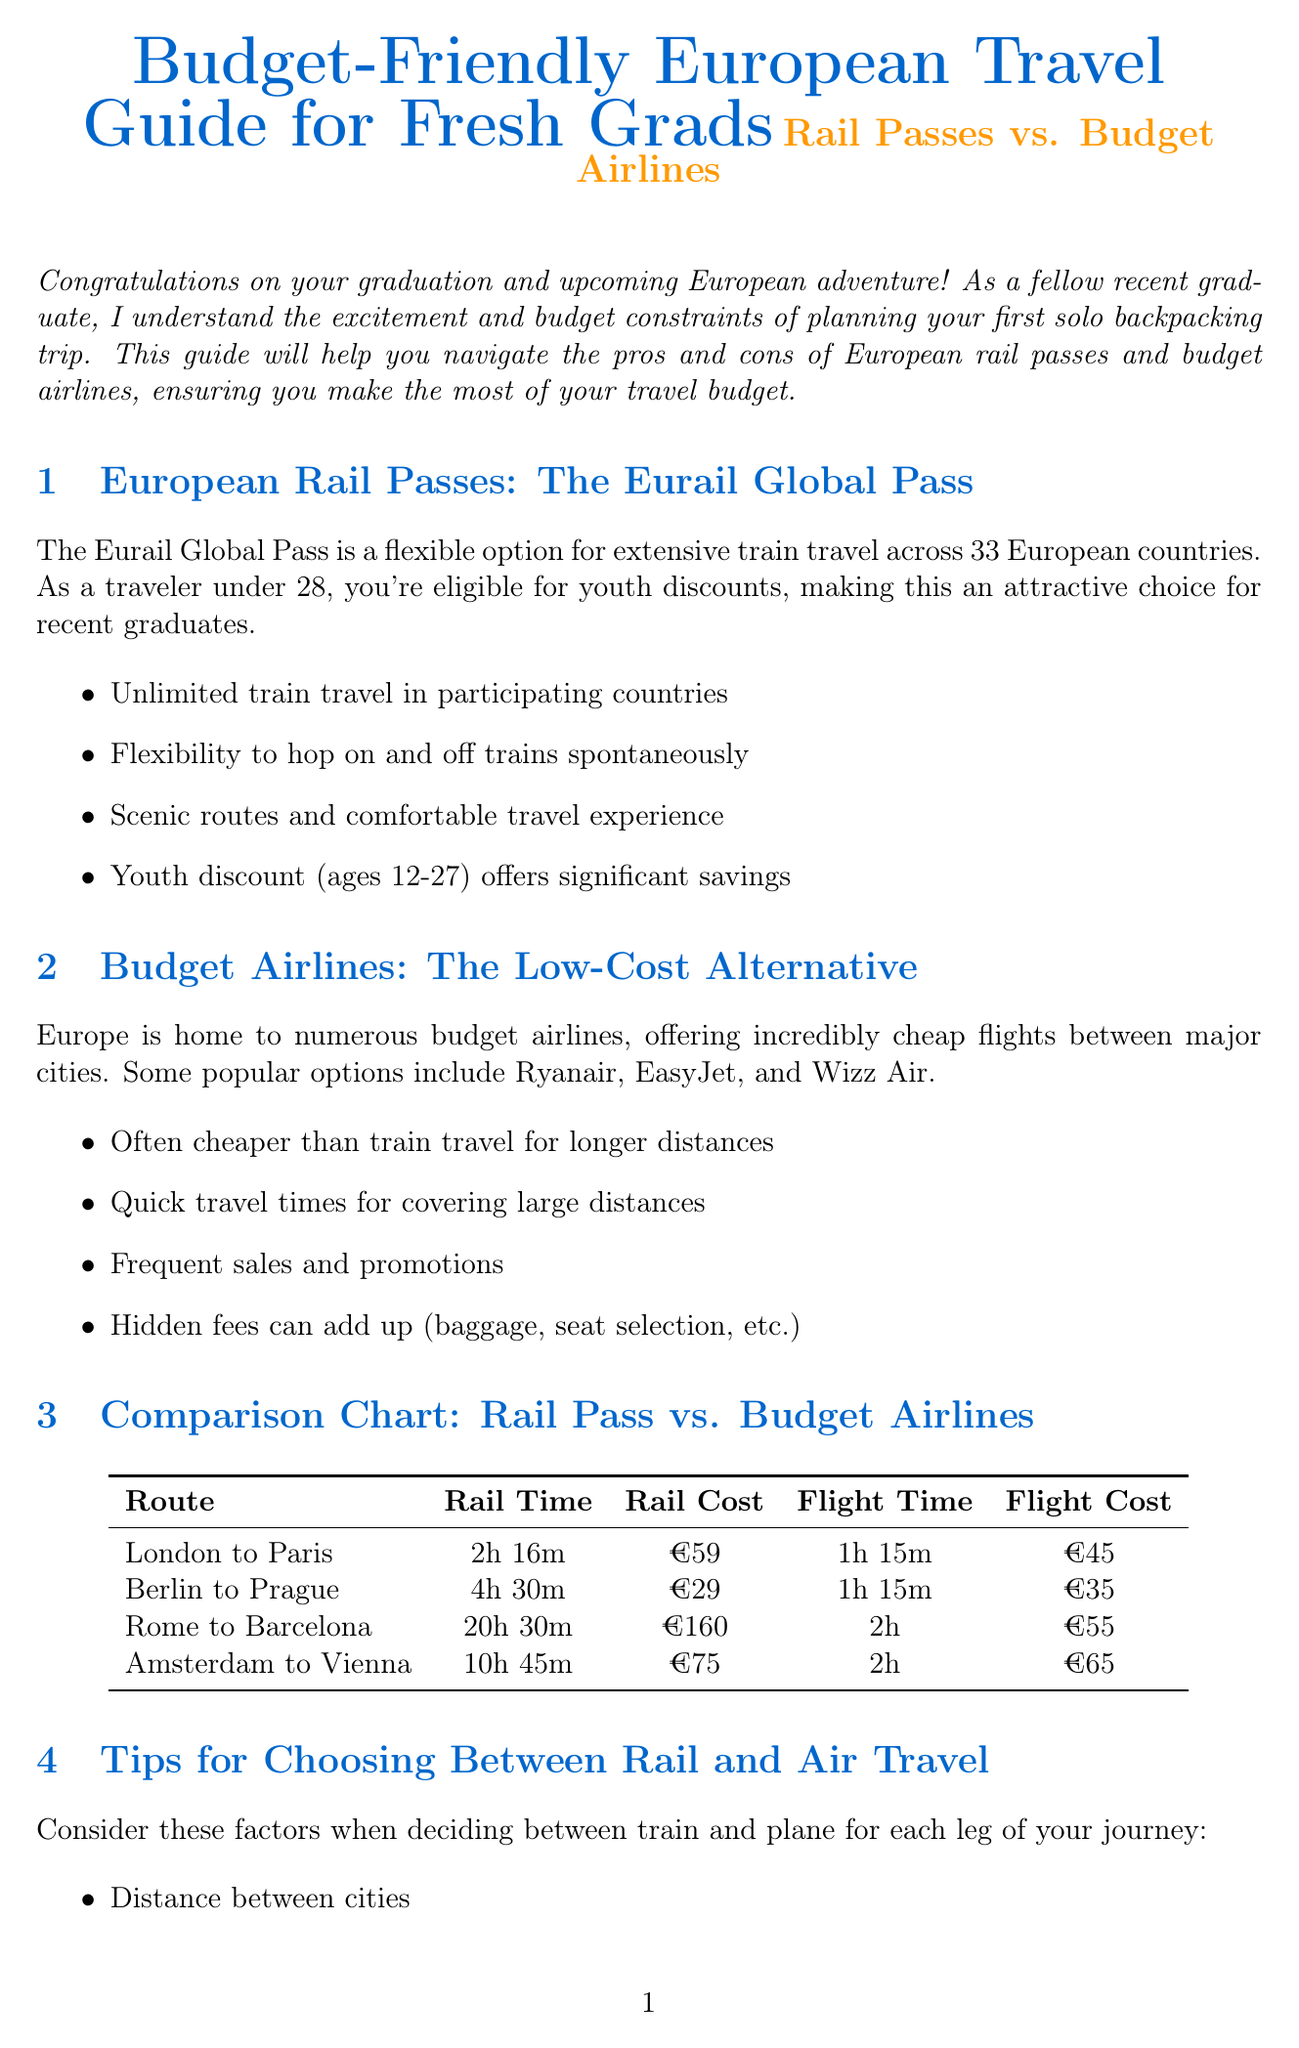What is the title of the newsletter? The title of the newsletter is explicitly stated at the start of the document.
Answer: Budget-Friendly European Travel Guide for Fresh Grads: Rail Passes vs. Budget Airlines What is the youth discount age range for the Eurail Global Pass? The document specifies the age range for youth discounts related to the Eurail Global Pass.
Answer: 12-27 Which budget airline is mentioned first in the newsletter? The document lists budget airlines and names them sequentially.
Answer: Ryanair What is the flight time from Berlin to Prague? The comparison chart provides details on travel times for specific routes.
Answer: 1h 15m What is the rail cost for the Amsterdam to Vienna route? The comparison chart lists costs specifically for rail travel on this route.
Answer: €75 What is a recommended strategy for saving money on travel? The document outlines various tips and tricks to maximize a travel budget.
Answer: Book train tickets and flights in advance for the best deals Which route has the longest rail time listed in the comparison chart? The comparison chart allows for analysis of rail times for all routes.
Answer: Rome to Barcelona What is one factor to consider when choosing between rail and air travel? The newsletter is dedicated to listing factors that influence travel decisions.
Answer: Distance between cities 